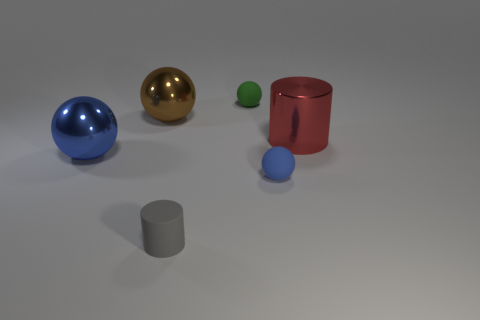How many large red metal cylinders are there?
Keep it short and to the point. 1. Is there a red cylinder that has the same material as the large blue object?
Provide a succinct answer. Yes. There is a ball to the left of the brown metal object; is it the same size as the blue sphere to the right of the tiny gray cylinder?
Offer a terse response. No. There is a metal object on the right side of the tiny green matte thing; what is its size?
Your response must be concise. Large. Are there any shiny spheres that have the same color as the tiny rubber cylinder?
Your answer should be very brief. No. Are there any metallic cylinders right of the big thing right of the small gray cylinder?
Your answer should be compact. No. There is a green rubber object; is its size the same as the metallic ball that is behind the red metallic cylinder?
Your answer should be very brief. No. There is a red cylinder that is on the right side of the tiny rubber thing that is in front of the tiny blue rubber ball; are there any green rubber spheres on the right side of it?
Give a very brief answer. No. What is the tiny sphere in front of the small green thing made of?
Offer a very short reply. Rubber. Do the matte cylinder and the green thing have the same size?
Your response must be concise. Yes. 